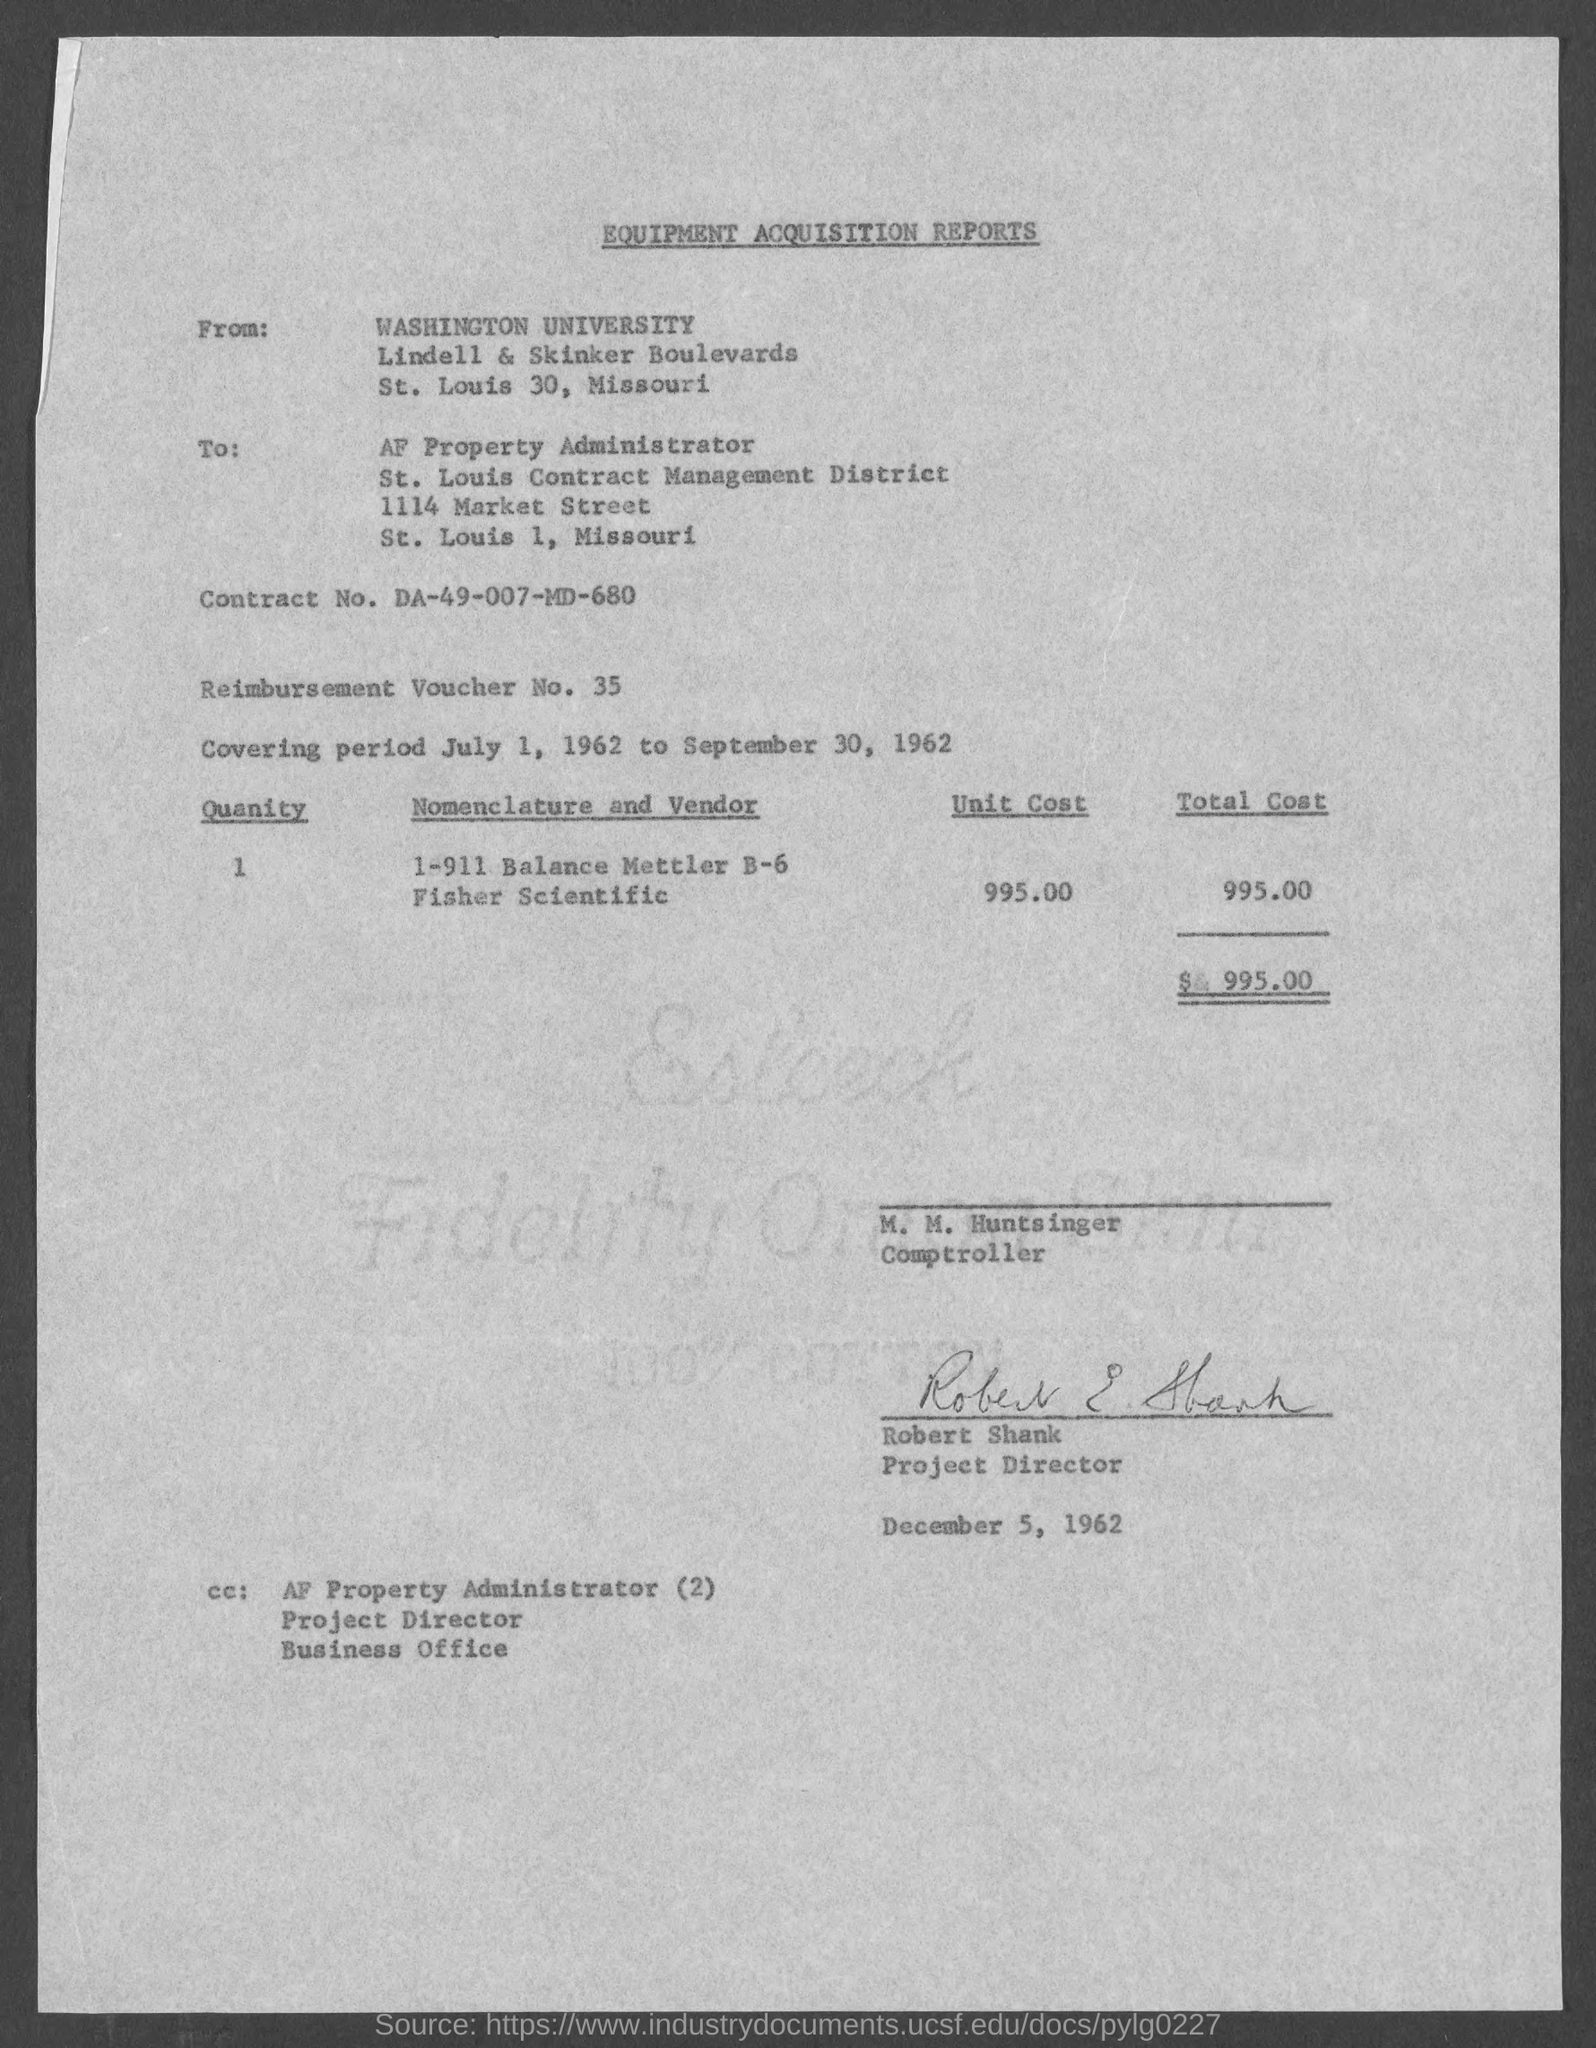From whom the report was sent ?
Provide a succinct answer. Washington university. To whom the letter was sent ?
Offer a very short reply. AF property administrator. What is the contract no. mentioned in the given form ?
Make the answer very short. Da-49-007-md-680. What is the reimbursement voucher no. mentioned in the given report ?
Make the answer very short. 35. What is the covering period mentioned in the given report ?
Provide a succinct answer. July 1, 1962 to september 30, 1962. What is the unit cost mentioned in the given report ?
Your answer should be very brief. 995.00. What is the total cost mentioned in the given page ?
Give a very brief answer. 995. What is the quantity mentioned in the given report ?
Keep it short and to the point. 1. 